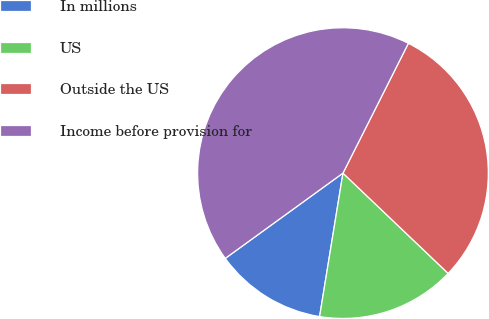<chart> <loc_0><loc_0><loc_500><loc_500><pie_chart><fcel>In millions<fcel>US<fcel>Outside the US<fcel>Income before provision for<nl><fcel>12.45%<fcel>15.45%<fcel>29.69%<fcel>42.41%<nl></chart> 